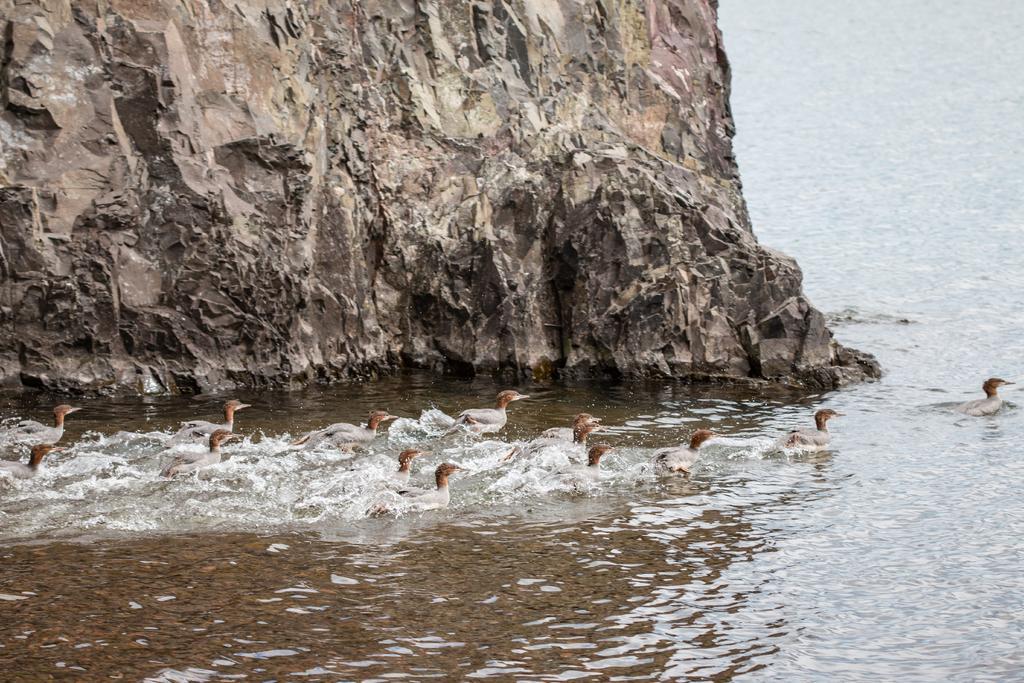Please provide a concise description of this image. In this picture we can see few birds and a rock in the water. 